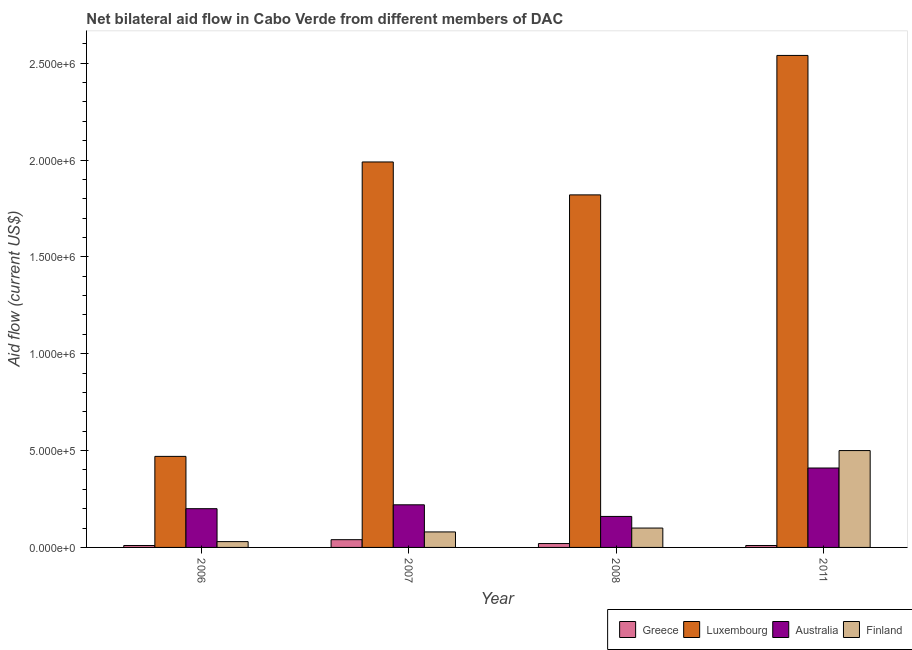How many different coloured bars are there?
Provide a short and direct response. 4. How many groups of bars are there?
Offer a terse response. 4. How many bars are there on the 1st tick from the left?
Make the answer very short. 4. How many bars are there on the 2nd tick from the right?
Your answer should be compact. 4. What is the label of the 1st group of bars from the left?
Keep it short and to the point. 2006. In how many cases, is the number of bars for a given year not equal to the number of legend labels?
Provide a succinct answer. 0. What is the amount of aid given by australia in 2006?
Your response must be concise. 2.00e+05. Across all years, what is the maximum amount of aid given by finland?
Provide a short and direct response. 5.00e+05. Across all years, what is the minimum amount of aid given by australia?
Offer a very short reply. 1.60e+05. What is the total amount of aid given by greece in the graph?
Offer a very short reply. 8.00e+04. What is the difference between the amount of aid given by luxembourg in 2008 and that in 2011?
Keep it short and to the point. -7.20e+05. What is the difference between the amount of aid given by luxembourg in 2008 and the amount of aid given by greece in 2011?
Your answer should be compact. -7.20e+05. What is the average amount of aid given by australia per year?
Keep it short and to the point. 2.48e+05. In how many years, is the amount of aid given by australia greater than 2500000 US$?
Make the answer very short. 0. What is the ratio of the amount of aid given by luxembourg in 2007 to that in 2008?
Provide a succinct answer. 1.09. Is the amount of aid given by australia in 2008 less than that in 2011?
Make the answer very short. Yes. Is the difference between the amount of aid given by greece in 2008 and 2011 greater than the difference between the amount of aid given by luxembourg in 2008 and 2011?
Provide a short and direct response. No. What is the difference between the highest and the second highest amount of aid given by luxembourg?
Your answer should be very brief. 5.50e+05. What is the difference between the highest and the lowest amount of aid given by greece?
Provide a succinct answer. 3.00e+04. In how many years, is the amount of aid given by greece greater than the average amount of aid given by greece taken over all years?
Your answer should be compact. 1. Is the sum of the amount of aid given by greece in 2007 and 2008 greater than the maximum amount of aid given by finland across all years?
Offer a very short reply. Yes. Is it the case that in every year, the sum of the amount of aid given by finland and amount of aid given by luxembourg is greater than the sum of amount of aid given by australia and amount of aid given by greece?
Your answer should be compact. Yes. What does the 3rd bar from the left in 2011 represents?
Provide a short and direct response. Australia. What does the 3rd bar from the right in 2008 represents?
Provide a short and direct response. Luxembourg. How many bars are there?
Ensure brevity in your answer.  16. How many years are there in the graph?
Make the answer very short. 4. What is the difference between two consecutive major ticks on the Y-axis?
Your answer should be very brief. 5.00e+05. Are the values on the major ticks of Y-axis written in scientific E-notation?
Make the answer very short. Yes. Does the graph contain grids?
Give a very brief answer. No. Where does the legend appear in the graph?
Ensure brevity in your answer.  Bottom right. How are the legend labels stacked?
Offer a terse response. Horizontal. What is the title of the graph?
Make the answer very short. Net bilateral aid flow in Cabo Verde from different members of DAC. Does "Services" appear as one of the legend labels in the graph?
Offer a terse response. No. What is the label or title of the Y-axis?
Provide a succinct answer. Aid flow (current US$). What is the Aid flow (current US$) of Luxembourg in 2006?
Your response must be concise. 4.70e+05. What is the Aid flow (current US$) in Finland in 2006?
Provide a short and direct response. 3.00e+04. What is the Aid flow (current US$) of Luxembourg in 2007?
Provide a short and direct response. 1.99e+06. What is the Aid flow (current US$) in Australia in 2007?
Ensure brevity in your answer.  2.20e+05. What is the Aid flow (current US$) of Luxembourg in 2008?
Give a very brief answer. 1.82e+06. What is the Aid flow (current US$) of Luxembourg in 2011?
Offer a very short reply. 2.54e+06. What is the Aid flow (current US$) of Australia in 2011?
Give a very brief answer. 4.10e+05. Across all years, what is the maximum Aid flow (current US$) of Luxembourg?
Offer a terse response. 2.54e+06. Across all years, what is the maximum Aid flow (current US$) of Australia?
Offer a terse response. 4.10e+05. Across all years, what is the minimum Aid flow (current US$) of Greece?
Provide a succinct answer. 10000. Across all years, what is the minimum Aid flow (current US$) of Luxembourg?
Offer a terse response. 4.70e+05. Across all years, what is the minimum Aid flow (current US$) in Australia?
Provide a succinct answer. 1.60e+05. Across all years, what is the minimum Aid flow (current US$) of Finland?
Keep it short and to the point. 3.00e+04. What is the total Aid flow (current US$) in Greece in the graph?
Give a very brief answer. 8.00e+04. What is the total Aid flow (current US$) in Luxembourg in the graph?
Keep it short and to the point. 6.82e+06. What is the total Aid flow (current US$) in Australia in the graph?
Provide a succinct answer. 9.90e+05. What is the total Aid flow (current US$) of Finland in the graph?
Provide a succinct answer. 7.10e+05. What is the difference between the Aid flow (current US$) in Greece in 2006 and that in 2007?
Your answer should be compact. -3.00e+04. What is the difference between the Aid flow (current US$) of Luxembourg in 2006 and that in 2007?
Offer a terse response. -1.52e+06. What is the difference between the Aid flow (current US$) in Australia in 2006 and that in 2007?
Keep it short and to the point. -2.00e+04. What is the difference between the Aid flow (current US$) of Luxembourg in 2006 and that in 2008?
Provide a short and direct response. -1.35e+06. What is the difference between the Aid flow (current US$) in Australia in 2006 and that in 2008?
Offer a terse response. 4.00e+04. What is the difference between the Aid flow (current US$) of Luxembourg in 2006 and that in 2011?
Keep it short and to the point. -2.07e+06. What is the difference between the Aid flow (current US$) of Australia in 2006 and that in 2011?
Your response must be concise. -2.10e+05. What is the difference between the Aid flow (current US$) in Finland in 2006 and that in 2011?
Keep it short and to the point. -4.70e+05. What is the difference between the Aid flow (current US$) of Greece in 2007 and that in 2008?
Your response must be concise. 2.00e+04. What is the difference between the Aid flow (current US$) in Australia in 2007 and that in 2008?
Provide a succinct answer. 6.00e+04. What is the difference between the Aid flow (current US$) in Greece in 2007 and that in 2011?
Provide a succinct answer. 3.00e+04. What is the difference between the Aid flow (current US$) of Luxembourg in 2007 and that in 2011?
Keep it short and to the point. -5.50e+05. What is the difference between the Aid flow (current US$) in Finland in 2007 and that in 2011?
Your answer should be very brief. -4.20e+05. What is the difference between the Aid flow (current US$) in Greece in 2008 and that in 2011?
Make the answer very short. 10000. What is the difference between the Aid flow (current US$) of Luxembourg in 2008 and that in 2011?
Give a very brief answer. -7.20e+05. What is the difference between the Aid flow (current US$) in Finland in 2008 and that in 2011?
Keep it short and to the point. -4.00e+05. What is the difference between the Aid flow (current US$) in Greece in 2006 and the Aid flow (current US$) in Luxembourg in 2007?
Make the answer very short. -1.98e+06. What is the difference between the Aid flow (current US$) in Luxembourg in 2006 and the Aid flow (current US$) in Finland in 2007?
Ensure brevity in your answer.  3.90e+05. What is the difference between the Aid flow (current US$) of Australia in 2006 and the Aid flow (current US$) of Finland in 2007?
Give a very brief answer. 1.20e+05. What is the difference between the Aid flow (current US$) of Greece in 2006 and the Aid flow (current US$) of Luxembourg in 2008?
Provide a succinct answer. -1.81e+06. What is the difference between the Aid flow (current US$) of Greece in 2006 and the Aid flow (current US$) of Finland in 2008?
Your answer should be compact. -9.00e+04. What is the difference between the Aid flow (current US$) in Luxembourg in 2006 and the Aid flow (current US$) in Finland in 2008?
Make the answer very short. 3.70e+05. What is the difference between the Aid flow (current US$) in Australia in 2006 and the Aid flow (current US$) in Finland in 2008?
Your response must be concise. 1.00e+05. What is the difference between the Aid flow (current US$) of Greece in 2006 and the Aid flow (current US$) of Luxembourg in 2011?
Provide a succinct answer. -2.53e+06. What is the difference between the Aid flow (current US$) in Greece in 2006 and the Aid flow (current US$) in Australia in 2011?
Provide a succinct answer. -4.00e+05. What is the difference between the Aid flow (current US$) in Greece in 2006 and the Aid flow (current US$) in Finland in 2011?
Your response must be concise. -4.90e+05. What is the difference between the Aid flow (current US$) in Luxembourg in 2006 and the Aid flow (current US$) in Australia in 2011?
Provide a short and direct response. 6.00e+04. What is the difference between the Aid flow (current US$) in Luxembourg in 2006 and the Aid flow (current US$) in Finland in 2011?
Offer a terse response. -3.00e+04. What is the difference between the Aid flow (current US$) in Greece in 2007 and the Aid flow (current US$) in Luxembourg in 2008?
Keep it short and to the point. -1.78e+06. What is the difference between the Aid flow (current US$) of Greece in 2007 and the Aid flow (current US$) of Finland in 2008?
Offer a very short reply. -6.00e+04. What is the difference between the Aid flow (current US$) of Luxembourg in 2007 and the Aid flow (current US$) of Australia in 2008?
Provide a short and direct response. 1.83e+06. What is the difference between the Aid flow (current US$) in Luxembourg in 2007 and the Aid flow (current US$) in Finland in 2008?
Provide a succinct answer. 1.89e+06. What is the difference between the Aid flow (current US$) in Greece in 2007 and the Aid flow (current US$) in Luxembourg in 2011?
Your response must be concise. -2.50e+06. What is the difference between the Aid flow (current US$) of Greece in 2007 and the Aid flow (current US$) of Australia in 2011?
Make the answer very short. -3.70e+05. What is the difference between the Aid flow (current US$) in Greece in 2007 and the Aid flow (current US$) in Finland in 2011?
Your answer should be very brief. -4.60e+05. What is the difference between the Aid flow (current US$) of Luxembourg in 2007 and the Aid flow (current US$) of Australia in 2011?
Provide a succinct answer. 1.58e+06. What is the difference between the Aid flow (current US$) of Luxembourg in 2007 and the Aid flow (current US$) of Finland in 2011?
Offer a very short reply. 1.49e+06. What is the difference between the Aid flow (current US$) in Australia in 2007 and the Aid flow (current US$) in Finland in 2011?
Keep it short and to the point. -2.80e+05. What is the difference between the Aid flow (current US$) of Greece in 2008 and the Aid flow (current US$) of Luxembourg in 2011?
Your answer should be very brief. -2.52e+06. What is the difference between the Aid flow (current US$) in Greece in 2008 and the Aid flow (current US$) in Australia in 2011?
Provide a short and direct response. -3.90e+05. What is the difference between the Aid flow (current US$) in Greece in 2008 and the Aid flow (current US$) in Finland in 2011?
Ensure brevity in your answer.  -4.80e+05. What is the difference between the Aid flow (current US$) in Luxembourg in 2008 and the Aid flow (current US$) in Australia in 2011?
Offer a very short reply. 1.41e+06. What is the difference between the Aid flow (current US$) in Luxembourg in 2008 and the Aid flow (current US$) in Finland in 2011?
Make the answer very short. 1.32e+06. What is the average Aid flow (current US$) in Greece per year?
Make the answer very short. 2.00e+04. What is the average Aid flow (current US$) of Luxembourg per year?
Give a very brief answer. 1.70e+06. What is the average Aid flow (current US$) of Australia per year?
Provide a short and direct response. 2.48e+05. What is the average Aid flow (current US$) of Finland per year?
Provide a short and direct response. 1.78e+05. In the year 2006, what is the difference between the Aid flow (current US$) in Greece and Aid flow (current US$) in Luxembourg?
Offer a terse response. -4.60e+05. In the year 2006, what is the difference between the Aid flow (current US$) of Greece and Aid flow (current US$) of Australia?
Keep it short and to the point. -1.90e+05. In the year 2006, what is the difference between the Aid flow (current US$) in Luxembourg and Aid flow (current US$) in Australia?
Provide a short and direct response. 2.70e+05. In the year 2006, what is the difference between the Aid flow (current US$) of Luxembourg and Aid flow (current US$) of Finland?
Offer a terse response. 4.40e+05. In the year 2006, what is the difference between the Aid flow (current US$) of Australia and Aid flow (current US$) of Finland?
Ensure brevity in your answer.  1.70e+05. In the year 2007, what is the difference between the Aid flow (current US$) of Greece and Aid flow (current US$) of Luxembourg?
Your answer should be compact. -1.95e+06. In the year 2007, what is the difference between the Aid flow (current US$) in Greece and Aid flow (current US$) in Australia?
Give a very brief answer. -1.80e+05. In the year 2007, what is the difference between the Aid flow (current US$) in Greece and Aid flow (current US$) in Finland?
Your answer should be very brief. -4.00e+04. In the year 2007, what is the difference between the Aid flow (current US$) of Luxembourg and Aid flow (current US$) of Australia?
Provide a short and direct response. 1.77e+06. In the year 2007, what is the difference between the Aid flow (current US$) of Luxembourg and Aid flow (current US$) of Finland?
Provide a succinct answer. 1.91e+06. In the year 2008, what is the difference between the Aid flow (current US$) in Greece and Aid flow (current US$) in Luxembourg?
Your answer should be compact. -1.80e+06. In the year 2008, what is the difference between the Aid flow (current US$) in Greece and Aid flow (current US$) in Australia?
Offer a very short reply. -1.40e+05. In the year 2008, what is the difference between the Aid flow (current US$) in Luxembourg and Aid flow (current US$) in Australia?
Provide a succinct answer. 1.66e+06. In the year 2008, what is the difference between the Aid flow (current US$) of Luxembourg and Aid flow (current US$) of Finland?
Give a very brief answer. 1.72e+06. In the year 2008, what is the difference between the Aid flow (current US$) in Australia and Aid flow (current US$) in Finland?
Give a very brief answer. 6.00e+04. In the year 2011, what is the difference between the Aid flow (current US$) in Greece and Aid flow (current US$) in Luxembourg?
Provide a succinct answer. -2.53e+06. In the year 2011, what is the difference between the Aid flow (current US$) of Greece and Aid flow (current US$) of Australia?
Give a very brief answer. -4.00e+05. In the year 2011, what is the difference between the Aid flow (current US$) in Greece and Aid flow (current US$) in Finland?
Keep it short and to the point. -4.90e+05. In the year 2011, what is the difference between the Aid flow (current US$) of Luxembourg and Aid flow (current US$) of Australia?
Your answer should be very brief. 2.13e+06. In the year 2011, what is the difference between the Aid flow (current US$) in Luxembourg and Aid flow (current US$) in Finland?
Your response must be concise. 2.04e+06. What is the ratio of the Aid flow (current US$) of Greece in 2006 to that in 2007?
Your answer should be compact. 0.25. What is the ratio of the Aid flow (current US$) in Luxembourg in 2006 to that in 2007?
Your answer should be compact. 0.24. What is the ratio of the Aid flow (current US$) in Finland in 2006 to that in 2007?
Make the answer very short. 0.38. What is the ratio of the Aid flow (current US$) in Greece in 2006 to that in 2008?
Your answer should be very brief. 0.5. What is the ratio of the Aid flow (current US$) in Luxembourg in 2006 to that in 2008?
Your answer should be very brief. 0.26. What is the ratio of the Aid flow (current US$) in Greece in 2006 to that in 2011?
Offer a very short reply. 1. What is the ratio of the Aid flow (current US$) of Luxembourg in 2006 to that in 2011?
Give a very brief answer. 0.18. What is the ratio of the Aid flow (current US$) of Australia in 2006 to that in 2011?
Your response must be concise. 0.49. What is the ratio of the Aid flow (current US$) in Luxembourg in 2007 to that in 2008?
Provide a succinct answer. 1.09. What is the ratio of the Aid flow (current US$) in Australia in 2007 to that in 2008?
Give a very brief answer. 1.38. What is the ratio of the Aid flow (current US$) in Greece in 2007 to that in 2011?
Keep it short and to the point. 4. What is the ratio of the Aid flow (current US$) in Luxembourg in 2007 to that in 2011?
Your answer should be very brief. 0.78. What is the ratio of the Aid flow (current US$) in Australia in 2007 to that in 2011?
Offer a terse response. 0.54. What is the ratio of the Aid flow (current US$) of Finland in 2007 to that in 2011?
Give a very brief answer. 0.16. What is the ratio of the Aid flow (current US$) in Greece in 2008 to that in 2011?
Keep it short and to the point. 2. What is the ratio of the Aid flow (current US$) of Luxembourg in 2008 to that in 2011?
Provide a succinct answer. 0.72. What is the ratio of the Aid flow (current US$) of Australia in 2008 to that in 2011?
Provide a succinct answer. 0.39. What is the difference between the highest and the second highest Aid flow (current US$) in Luxembourg?
Offer a very short reply. 5.50e+05. What is the difference between the highest and the second highest Aid flow (current US$) in Australia?
Keep it short and to the point. 1.90e+05. What is the difference between the highest and the lowest Aid flow (current US$) in Luxembourg?
Keep it short and to the point. 2.07e+06. What is the difference between the highest and the lowest Aid flow (current US$) of Australia?
Keep it short and to the point. 2.50e+05. 